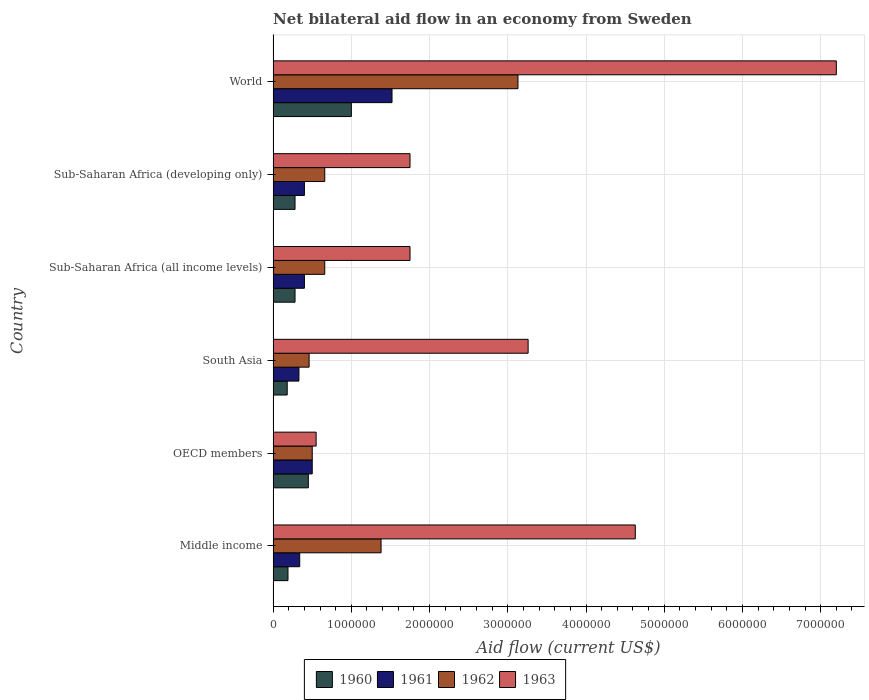How many different coloured bars are there?
Give a very brief answer. 4. How many groups of bars are there?
Give a very brief answer. 6. What is the net bilateral aid flow in 1960 in OECD members?
Make the answer very short. 4.50e+05. Across all countries, what is the maximum net bilateral aid flow in 1963?
Ensure brevity in your answer.  7.20e+06. Across all countries, what is the minimum net bilateral aid flow in 1961?
Provide a succinct answer. 3.30e+05. What is the total net bilateral aid flow in 1960 in the graph?
Provide a succinct answer. 2.38e+06. What is the difference between the net bilateral aid flow in 1960 in Middle income and the net bilateral aid flow in 1963 in World?
Your response must be concise. -7.01e+06. What is the average net bilateral aid flow in 1960 per country?
Provide a short and direct response. 3.97e+05. What is the difference between the net bilateral aid flow in 1962 and net bilateral aid flow in 1960 in Middle income?
Your answer should be very brief. 1.19e+06. In how many countries, is the net bilateral aid flow in 1961 greater than 1600000 US$?
Make the answer very short. 0. What is the ratio of the net bilateral aid flow in 1961 in Sub-Saharan Africa (all income levels) to that in World?
Keep it short and to the point. 0.26. What is the difference between the highest and the second highest net bilateral aid flow in 1963?
Give a very brief answer. 2.57e+06. What is the difference between the highest and the lowest net bilateral aid flow in 1963?
Make the answer very short. 6.65e+06. What does the 1st bar from the top in South Asia represents?
Offer a terse response. 1963. What does the 3rd bar from the bottom in OECD members represents?
Provide a succinct answer. 1962. Is it the case that in every country, the sum of the net bilateral aid flow in 1963 and net bilateral aid flow in 1960 is greater than the net bilateral aid flow in 1962?
Give a very brief answer. Yes. Are all the bars in the graph horizontal?
Provide a short and direct response. Yes. How many countries are there in the graph?
Provide a short and direct response. 6. Are the values on the major ticks of X-axis written in scientific E-notation?
Offer a terse response. No. Does the graph contain any zero values?
Give a very brief answer. No. How are the legend labels stacked?
Your answer should be compact. Horizontal. What is the title of the graph?
Your answer should be compact. Net bilateral aid flow in an economy from Sweden. What is the Aid flow (current US$) in 1962 in Middle income?
Your response must be concise. 1.38e+06. What is the Aid flow (current US$) in 1963 in Middle income?
Your response must be concise. 4.63e+06. What is the Aid flow (current US$) in 1961 in OECD members?
Give a very brief answer. 5.00e+05. What is the Aid flow (current US$) in 1962 in OECD members?
Make the answer very short. 5.00e+05. What is the Aid flow (current US$) in 1963 in OECD members?
Keep it short and to the point. 5.50e+05. What is the Aid flow (current US$) in 1962 in South Asia?
Provide a short and direct response. 4.60e+05. What is the Aid flow (current US$) of 1963 in South Asia?
Your answer should be compact. 3.26e+06. What is the Aid flow (current US$) in 1961 in Sub-Saharan Africa (all income levels)?
Your response must be concise. 4.00e+05. What is the Aid flow (current US$) in 1962 in Sub-Saharan Africa (all income levels)?
Provide a succinct answer. 6.60e+05. What is the Aid flow (current US$) of 1963 in Sub-Saharan Africa (all income levels)?
Your response must be concise. 1.75e+06. What is the Aid flow (current US$) of 1960 in Sub-Saharan Africa (developing only)?
Make the answer very short. 2.80e+05. What is the Aid flow (current US$) in 1961 in Sub-Saharan Africa (developing only)?
Your answer should be compact. 4.00e+05. What is the Aid flow (current US$) in 1962 in Sub-Saharan Africa (developing only)?
Make the answer very short. 6.60e+05. What is the Aid flow (current US$) of 1963 in Sub-Saharan Africa (developing only)?
Ensure brevity in your answer.  1.75e+06. What is the Aid flow (current US$) of 1960 in World?
Offer a terse response. 1.00e+06. What is the Aid flow (current US$) in 1961 in World?
Offer a very short reply. 1.52e+06. What is the Aid flow (current US$) of 1962 in World?
Your answer should be compact. 3.13e+06. What is the Aid flow (current US$) of 1963 in World?
Ensure brevity in your answer.  7.20e+06. Across all countries, what is the maximum Aid flow (current US$) of 1961?
Offer a terse response. 1.52e+06. Across all countries, what is the maximum Aid flow (current US$) of 1962?
Keep it short and to the point. 3.13e+06. Across all countries, what is the maximum Aid flow (current US$) in 1963?
Your response must be concise. 7.20e+06. Across all countries, what is the minimum Aid flow (current US$) of 1960?
Offer a terse response. 1.80e+05. Across all countries, what is the minimum Aid flow (current US$) in 1961?
Offer a terse response. 3.30e+05. Across all countries, what is the minimum Aid flow (current US$) in 1962?
Your answer should be very brief. 4.60e+05. Across all countries, what is the minimum Aid flow (current US$) of 1963?
Provide a succinct answer. 5.50e+05. What is the total Aid flow (current US$) in 1960 in the graph?
Your response must be concise. 2.38e+06. What is the total Aid flow (current US$) in 1961 in the graph?
Make the answer very short. 3.49e+06. What is the total Aid flow (current US$) in 1962 in the graph?
Offer a terse response. 6.79e+06. What is the total Aid flow (current US$) of 1963 in the graph?
Offer a terse response. 1.91e+07. What is the difference between the Aid flow (current US$) in 1960 in Middle income and that in OECD members?
Provide a short and direct response. -2.60e+05. What is the difference between the Aid flow (current US$) of 1962 in Middle income and that in OECD members?
Your answer should be compact. 8.80e+05. What is the difference between the Aid flow (current US$) in 1963 in Middle income and that in OECD members?
Ensure brevity in your answer.  4.08e+06. What is the difference between the Aid flow (current US$) of 1960 in Middle income and that in South Asia?
Keep it short and to the point. 10000. What is the difference between the Aid flow (current US$) in 1961 in Middle income and that in South Asia?
Keep it short and to the point. 10000. What is the difference between the Aid flow (current US$) in 1962 in Middle income and that in South Asia?
Offer a terse response. 9.20e+05. What is the difference between the Aid flow (current US$) in 1963 in Middle income and that in South Asia?
Provide a succinct answer. 1.37e+06. What is the difference between the Aid flow (current US$) of 1962 in Middle income and that in Sub-Saharan Africa (all income levels)?
Your answer should be compact. 7.20e+05. What is the difference between the Aid flow (current US$) in 1963 in Middle income and that in Sub-Saharan Africa (all income levels)?
Give a very brief answer. 2.88e+06. What is the difference between the Aid flow (current US$) of 1962 in Middle income and that in Sub-Saharan Africa (developing only)?
Offer a terse response. 7.20e+05. What is the difference between the Aid flow (current US$) in 1963 in Middle income and that in Sub-Saharan Africa (developing only)?
Your answer should be very brief. 2.88e+06. What is the difference between the Aid flow (current US$) of 1960 in Middle income and that in World?
Provide a short and direct response. -8.10e+05. What is the difference between the Aid flow (current US$) in 1961 in Middle income and that in World?
Ensure brevity in your answer.  -1.18e+06. What is the difference between the Aid flow (current US$) of 1962 in Middle income and that in World?
Ensure brevity in your answer.  -1.75e+06. What is the difference between the Aid flow (current US$) of 1963 in Middle income and that in World?
Give a very brief answer. -2.57e+06. What is the difference between the Aid flow (current US$) in 1960 in OECD members and that in South Asia?
Provide a succinct answer. 2.70e+05. What is the difference between the Aid flow (current US$) of 1963 in OECD members and that in South Asia?
Provide a succinct answer. -2.71e+06. What is the difference between the Aid flow (current US$) of 1960 in OECD members and that in Sub-Saharan Africa (all income levels)?
Offer a very short reply. 1.70e+05. What is the difference between the Aid flow (current US$) of 1961 in OECD members and that in Sub-Saharan Africa (all income levels)?
Your answer should be compact. 1.00e+05. What is the difference between the Aid flow (current US$) of 1963 in OECD members and that in Sub-Saharan Africa (all income levels)?
Offer a very short reply. -1.20e+06. What is the difference between the Aid flow (current US$) of 1960 in OECD members and that in Sub-Saharan Africa (developing only)?
Ensure brevity in your answer.  1.70e+05. What is the difference between the Aid flow (current US$) of 1961 in OECD members and that in Sub-Saharan Africa (developing only)?
Give a very brief answer. 1.00e+05. What is the difference between the Aid flow (current US$) in 1962 in OECD members and that in Sub-Saharan Africa (developing only)?
Your response must be concise. -1.60e+05. What is the difference between the Aid flow (current US$) of 1963 in OECD members and that in Sub-Saharan Africa (developing only)?
Offer a very short reply. -1.20e+06. What is the difference between the Aid flow (current US$) in 1960 in OECD members and that in World?
Your answer should be very brief. -5.50e+05. What is the difference between the Aid flow (current US$) in 1961 in OECD members and that in World?
Offer a terse response. -1.02e+06. What is the difference between the Aid flow (current US$) of 1962 in OECD members and that in World?
Keep it short and to the point. -2.63e+06. What is the difference between the Aid flow (current US$) of 1963 in OECD members and that in World?
Your response must be concise. -6.65e+06. What is the difference between the Aid flow (current US$) in 1961 in South Asia and that in Sub-Saharan Africa (all income levels)?
Provide a short and direct response. -7.00e+04. What is the difference between the Aid flow (current US$) in 1963 in South Asia and that in Sub-Saharan Africa (all income levels)?
Your answer should be compact. 1.51e+06. What is the difference between the Aid flow (current US$) in 1962 in South Asia and that in Sub-Saharan Africa (developing only)?
Ensure brevity in your answer.  -2.00e+05. What is the difference between the Aid flow (current US$) in 1963 in South Asia and that in Sub-Saharan Africa (developing only)?
Provide a short and direct response. 1.51e+06. What is the difference between the Aid flow (current US$) of 1960 in South Asia and that in World?
Ensure brevity in your answer.  -8.20e+05. What is the difference between the Aid flow (current US$) in 1961 in South Asia and that in World?
Offer a terse response. -1.19e+06. What is the difference between the Aid flow (current US$) in 1962 in South Asia and that in World?
Your answer should be very brief. -2.67e+06. What is the difference between the Aid flow (current US$) in 1963 in South Asia and that in World?
Offer a very short reply. -3.94e+06. What is the difference between the Aid flow (current US$) in 1960 in Sub-Saharan Africa (all income levels) and that in Sub-Saharan Africa (developing only)?
Your answer should be very brief. 0. What is the difference between the Aid flow (current US$) in 1962 in Sub-Saharan Africa (all income levels) and that in Sub-Saharan Africa (developing only)?
Offer a very short reply. 0. What is the difference between the Aid flow (current US$) of 1963 in Sub-Saharan Africa (all income levels) and that in Sub-Saharan Africa (developing only)?
Ensure brevity in your answer.  0. What is the difference between the Aid flow (current US$) in 1960 in Sub-Saharan Africa (all income levels) and that in World?
Offer a very short reply. -7.20e+05. What is the difference between the Aid flow (current US$) of 1961 in Sub-Saharan Africa (all income levels) and that in World?
Make the answer very short. -1.12e+06. What is the difference between the Aid flow (current US$) of 1962 in Sub-Saharan Africa (all income levels) and that in World?
Your answer should be compact. -2.47e+06. What is the difference between the Aid flow (current US$) in 1963 in Sub-Saharan Africa (all income levels) and that in World?
Offer a very short reply. -5.45e+06. What is the difference between the Aid flow (current US$) in 1960 in Sub-Saharan Africa (developing only) and that in World?
Make the answer very short. -7.20e+05. What is the difference between the Aid flow (current US$) in 1961 in Sub-Saharan Africa (developing only) and that in World?
Ensure brevity in your answer.  -1.12e+06. What is the difference between the Aid flow (current US$) in 1962 in Sub-Saharan Africa (developing only) and that in World?
Keep it short and to the point. -2.47e+06. What is the difference between the Aid flow (current US$) of 1963 in Sub-Saharan Africa (developing only) and that in World?
Provide a short and direct response. -5.45e+06. What is the difference between the Aid flow (current US$) in 1960 in Middle income and the Aid flow (current US$) in 1961 in OECD members?
Keep it short and to the point. -3.10e+05. What is the difference between the Aid flow (current US$) of 1960 in Middle income and the Aid flow (current US$) of 1962 in OECD members?
Your answer should be very brief. -3.10e+05. What is the difference between the Aid flow (current US$) of 1960 in Middle income and the Aid flow (current US$) of 1963 in OECD members?
Provide a short and direct response. -3.60e+05. What is the difference between the Aid flow (current US$) in 1961 in Middle income and the Aid flow (current US$) in 1963 in OECD members?
Keep it short and to the point. -2.10e+05. What is the difference between the Aid flow (current US$) in 1962 in Middle income and the Aid flow (current US$) in 1963 in OECD members?
Your answer should be very brief. 8.30e+05. What is the difference between the Aid flow (current US$) in 1960 in Middle income and the Aid flow (current US$) in 1963 in South Asia?
Provide a succinct answer. -3.07e+06. What is the difference between the Aid flow (current US$) in 1961 in Middle income and the Aid flow (current US$) in 1962 in South Asia?
Your answer should be compact. -1.20e+05. What is the difference between the Aid flow (current US$) in 1961 in Middle income and the Aid flow (current US$) in 1963 in South Asia?
Keep it short and to the point. -2.92e+06. What is the difference between the Aid flow (current US$) of 1962 in Middle income and the Aid flow (current US$) of 1963 in South Asia?
Your answer should be very brief. -1.88e+06. What is the difference between the Aid flow (current US$) in 1960 in Middle income and the Aid flow (current US$) in 1961 in Sub-Saharan Africa (all income levels)?
Ensure brevity in your answer.  -2.10e+05. What is the difference between the Aid flow (current US$) in 1960 in Middle income and the Aid flow (current US$) in 1962 in Sub-Saharan Africa (all income levels)?
Offer a very short reply. -4.70e+05. What is the difference between the Aid flow (current US$) in 1960 in Middle income and the Aid flow (current US$) in 1963 in Sub-Saharan Africa (all income levels)?
Provide a short and direct response. -1.56e+06. What is the difference between the Aid flow (current US$) in 1961 in Middle income and the Aid flow (current US$) in 1962 in Sub-Saharan Africa (all income levels)?
Keep it short and to the point. -3.20e+05. What is the difference between the Aid flow (current US$) in 1961 in Middle income and the Aid flow (current US$) in 1963 in Sub-Saharan Africa (all income levels)?
Provide a succinct answer. -1.41e+06. What is the difference between the Aid flow (current US$) in 1962 in Middle income and the Aid flow (current US$) in 1963 in Sub-Saharan Africa (all income levels)?
Give a very brief answer. -3.70e+05. What is the difference between the Aid flow (current US$) of 1960 in Middle income and the Aid flow (current US$) of 1962 in Sub-Saharan Africa (developing only)?
Give a very brief answer. -4.70e+05. What is the difference between the Aid flow (current US$) in 1960 in Middle income and the Aid flow (current US$) in 1963 in Sub-Saharan Africa (developing only)?
Provide a short and direct response. -1.56e+06. What is the difference between the Aid flow (current US$) of 1961 in Middle income and the Aid flow (current US$) of 1962 in Sub-Saharan Africa (developing only)?
Make the answer very short. -3.20e+05. What is the difference between the Aid flow (current US$) in 1961 in Middle income and the Aid flow (current US$) in 1963 in Sub-Saharan Africa (developing only)?
Your response must be concise. -1.41e+06. What is the difference between the Aid flow (current US$) in 1962 in Middle income and the Aid flow (current US$) in 1963 in Sub-Saharan Africa (developing only)?
Your response must be concise. -3.70e+05. What is the difference between the Aid flow (current US$) of 1960 in Middle income and the Aid flow (current US$) of 1961 in World?
Make the answer very short. -1.33e+06. What is the difference between the Aid flow (current US$) in 1960 in Middle income and the Aid flow (current US$) in 1962 in World?
Give a very brief answer. -2.94e+06. What is the difference between the Aid flow (current US$) in 1960 in Middle income and the Aid flow (current US$) in 1963 in World?
Your answer should be very brief. -7.01e+06. What is the difference between the Aid flow (current US$) of 1961 in Middle income and the Aid flow (current US$) of 1962 in World?
Your answer should be compact. -2.79e+06. What is the difference between the Aid flow (current US$) in 1961 in Middle income and the Aid flow (current US$) in 1963 in World?
Provide a succinct answer. -6.86e+06. What is the difference between the Aid flow (current US$) of 1962 in Middle income and the Aid flow (current US$) of 1963 in World?
Your response must be concise. -5.82e+06. What is the difference between the Aid flow (current US$) in 1960 in OECD members and the Aid flow (current US$) in 1962 in South Asia?
Your answer should be compact. -10000. What is the difference between the Aid flow (current US$) of 1960 in OECD members and the Aid flow (current US$) of 1963 in South Asia?
Your answer should be compact. -2.81e+06. What is the difference between the Aid flow (current US$) of 1961 in OECD members and the Aid flow (current US$) of 1962 in South Asia?
Your answer should be very brief. 4.00e+04. What is the difference between the Aid flow (current US$) in 1961 in OECD members and the Aid flow (current US$) in 1963 in South Asia?
Keep it short and to the point. -2.76e+06. What is the difference between the Aid flow (current US$) of 1962 in OECD members and the Aid flow (current US$) of 1963 in South Asia?
Make the answer very short. -2.76e+06. What is the difference between the Aid flow (current US$) of 1960 in OECD members and the Aid flow (current US$) of 1963 in Sub-Saharan Africa (all income levels)?
Offer a very short reply. -1.30e+06. What is the difference between the Aid flow (current US$) in 1961 in OECD members and the Aid flow (current US$) in 1962 in Sub-Saharan Africa (all income levels)?
Make the answer very short. -1.60e+05. What is the difference between the Aid flow (current US$) in 1961 in OECD members and the Aid flow (current US$) in 1963 in Sub-Saharan Africa (all income levels)?
Provide a succinct answer. -1.25e+06. What is the difference between the Aid flow (current US$) in 1962 in OECD members and the Aid flow (current US$) in 1963 in Sub-Saharan Africa (all income levels)?
Make the answer very short. -1.25e+06. What is the difference between the Aid flow (current US$) of 1960 in OECD members and the Aid flow (current US$) of 1961 in Sub-Saharan Africa (developing only)?
Your answer should be compact. 5.00e+04. What is the difference between the Aid flow (current US$) in 1960 in OECD members and the Aid flow (current US$) in 1962 in Sub-Saharan Africa (developing only)?
Keep it short and to the point. -2.10e+05. What is the difference between the Aid flow (current US$) in 1960 in OECD members and the Aid flow (current US$) in 1963 in Sub-Saharan Africa (developing only)?
Provide a short and direct response. -1.30e+06. What is the difference between the Aid flow (current US$) in 1961 in OECD members and the Aid flow (current US$) in 1962 in Sub-Saharan Africa (developing only)?
Provide a succinct answer. -1.60e+05. What is the difference between the Aid flow (current US$) of 1961 in OECD members and the Aid flow (current US$) of 1963 in Sub-Saharan Africa (developing only)?
Offer a terse response. -1.25e+06. What is the difference between the Aid flow (current US$) of 1962 in OECD members and the Aid flow (current US$) of 1963 in Sub-Saharan Africa (developing only)?
Make the answer very short. -1.25e+06. What is the difference between the Aid flow (current US$) in 1960 in OECD members and the Aid flow (current US$) in 1961 in World?
Your answer should be very brief. -1.07e+06. What is the difference between the Aid flow (current US$) in 1960 in OECD members and the Aid flow (current US$) in 1962 in World?
Provide a short and direct response. -2.68e+06. What is the difference between the Aid flow (current US$) of 1960 in OECD members and the Aid flow (current US$) of 1963 in World?
Offer a terse response. -6.75e+06. What is the difference between the Aid flow (current US$) in 1961 in OECD members and the Aid flow (current US$) in 1962 in World?
Keep it short and to the point. -2.63e+06. What is the difference between the Aid flow (current US$) in 1961 in OECD members and the Aid flow (current US$) in 1963 in World?
Ensure brevity in your answer.  -6.70e+06. What is the difference between the Aid flow (current US$) of 1962 in OECD members and the Aid flow (current US$) of 1963 in World?
Your answer should be compact. -6.70e+06. What is the difference between the Aid flow (current US$) in 1960 in South Asia and the Aid flow (current US$) in 1961 in Sub-Saharan Africa (all income levels)?
Ensure brevity in your answer.  -2.20e+05. What is the difference between the Aid flow (current US$) of 1960 in South Asia and the Aid flow (current US$) of 1962 in Sub-Saharan Africa (all income levels)?
Give a very brief answer. -4.80e+05. What is the difference between the Aid flow (current US$) of 1960 in South Asia and the Aid flow (current US$) of 1963 in Sub-Saharan Africa (all income levels)?
Your answer should be compact. -1.57e+06. What is the difference between the Aid flow (current US$) of 1961 in South Asia and the Aid flow (current US$) of 1962 in Sub-Saharan Africa (all income levels)?
Your answer should be very brief. -3.30e+05. What is the difference between the Aid flow (current US$) in 1961 in South Asia and the Aid flow (current US$) in 1963 in Sub-Saharan Africa (all income levels)?
Provide a succinct answer. -1.42e+06. What is the difference between the Aid flow (current US$) of 1962 in South Asia and the Aid flow (current US$) of 1963 in Sub-Saharan Africa (all income levels)?
Your answer should be compact. -1.29e+06. What is the difference between the Aid flow (current US$) in 1960 in South Asia and the Aid flow (current US$) in 1962 in Sub-Saharan Africa (developing only)?
Your answer should be compact. -4.80e+05. What is the difference between the Aid flow (current US$) of 1960 in South Asia and the Aid flow (current US$) of 1963 in Sub-Saharan Africa (developing only)?
Make the answer very short. -1.57e+06. What is the difference between the Aid flow (current US$) in 1961 in South Asia and the Aid flow (current US$) in 1962 in Sub-Saharan Africa (developing only)?
Give a very brief answer. -3.30e+05. What is the difference between the Aid flow (current US$) in 1961 in South Asia and the Aid flow (current US$) in 1963 in Sub-Saharan Africa (developing only)?
Your response must be concise. -1.42e+06. What is the difference between the Aid flow (current US$) of 1962 in South Asia and the Aid flow (current US$) of 1963 in Sub-Saharan Africa (developing only)?
Keep it short and to the point. -1.29e+06. What is the difference between the Aid flow (current US$) in 1960 in South Asia and the Aid flow (current US$) in 1961 in World?
Make the answer very short. -1.34e+06. What is the difference between the Aid flow (current US$) of 1960 in South Asia and the Aid flow (current US$) of 1962 in World?
Offer a terse response. -2.95e+06. What is the difference between the Aid flow (current US$) of 1960 in South Asia and the Aid flow (current US$) of 1963 in World?
Offer a terse response. -7.02e+06. What is the difference between the Aid flow (current US$) in 1961 in South Asia and the Aid flow (current US$) in 1962 in World?
Offer a very short reply. -2.80e+06. What is the difference between the Aid flow (current US$) in 1961 in South Asia and the Aid flow (current US$) in 1963 in World?
Provide a succinct answer. -6.87e+06. What is the difference between the Aid flow (current US$) in 1962 in South Asia and the Aid flow (current US$) in 1963 in World?
Offer a terse response. -6.74e+06. What is the difference between the Aid flow (current US$) in 1960 in Sub-Saharan Africa (all income levels) and the Aid flow (current US$) in 1961 in Sub-Saharan Africa (developing only)?
Your answer should be compact. -1.20e+05. What is the difference between the Aid flow (current US$) in 1960 in Sub-Saharan Africa (all income levels) and the Aid flow (current US$) in 1962 in Sub-Saharan Africa (developing only)?
Your answer should be very brief. -3.80e+05. What is the difference between the Aid flow (current US$) in 1960 in Sub-Saharan Africa (all income levels) and the Aid flow (current US$) in 1963 in Sub-Saharan Africa (developing only)?
Keep it short and to the point. -1.47e+06. What is the difference between the Aid flow (current US$) in 1961 in Sub-Saharan Africa (all income levels) and the Aid flow (current US$) in 1962 in Sub-Saharan Africa (developing only)?
Your answer should be compact. -2.60e+05. What is the difference between the Aid flow (current US$) of 1961 in Sub-Saharan Africa (all income levels) and the Aid flow (current US$) of 1963 in Sub-Saharan Africa (developing only)?
Give a very brief answer. -1.35e+06. What is the difference between the Aid flow (current US$) of 1962 in Sub-Saharan Africa (all income levels) and the Aid flow (current US$) of 1963 in Sub-Saharan Africa (developing only)?
Keep it short and to the point. -1.09e+06. What is the difference between the Aid flow (current US$) in 1960 in Sub-Saharan Africa (all income levels) and the Aid flow (current US$) in 1961 in World?
Offer a terse response. -1.24e+06. What is the difference between the Aid flow (current US$) of 1960 in Sub-Saharan Africa (all income levels) and the Aid flow (current US$) of 1962 in World?
Provide a succinct answer. -2.85e+06. What is the difference between the Aid flow (current US$) in 1960 in Sub-Saharan Africa (all income levels) and the Aid flow (current US$) in 1963 in World?
Ensure brevity in your answer.  -6.92e+06. What is the difference between the Aid flow (current US$) of 1961 in Sub-Saharan Africa (all income levels) and the Aid flow (current US$) of 1962 in World?
Provide a succinct answer. -2.73e+06. What is the difference between the Aid flow (current US$) of 1961 in Sub-Saharan Africa (all income levels) and the Aid flow (current US$) of 1963 in World?
Your answer should be compact. -6.80e+06. What is the difference between the Aid flow (current US$) of 1962 in Sub-Saharan Africa (all income levels) and the Aid flow (current US$) of 1963 in World?
Keep it short and to the point. -6.54e+06. What is the difference between the Aid flow (current US$) of 1960 in Sub-Saharan Africa (developing only) and the Aid flow (current US$) of 1961 in World?
Offer a very short reply. -1.24e+06. What is the difference between the Aid flow (current US$) in 1960 in Sub-Saharan Africa (developing only) and the Aid flow (current US$) in 1962 in World?
Your answer should be compact. -2.85e+06. What is the difference between the Aid flow (current US$) of 1960 in Sub-Saharan Africa (developing only) and the Aid flow (current US$) of 1963 in World?
Keep it short and to the point. -6.92e+06. What is the difference between the Aid flow (current US$) in 1961 in Sub-Saharan Africa (developing only) and the Aid flow (current US$) in 1962 in World?
Provide a succinct answer. -2.73e+06. What is the difference between the Aid flow (current US$) of 1961 in Sub-Saharan Africa (developing only) and the Aid flow (current US$) of 1963 in World?
Make the answer very short. -6.80e+06. What is the difference between the Aid flow (current US$) of 1962 in Sub-Saharan Africa (developing only) and the Aid flow (current US$) of 1963 in World?
Your response must be concise. -6.54e+06. What is the average Aid flow (current US$) of 1960 per country?
Keep it short and to the point. 3.97e+05. What is the average Aid flow (current US$) in 1961 per country?
Provide a short and direct response. 5.82e+05. What is the average Aid flow (current US$) of 1962 per country?
Provide a short and direct response. 1.13e+06. What is the average Aid flow (current US$) of 1963 per country?
Provide a succinct answer. 3.19e+06. What is the difference between the Aid flow (current US$) of 1960 and Aid flow (current US$) of 1962 in Middle income?
Offer a very short reply. -1.19e+06. What is the difference between the Aid flow (current US$) in 1960 and Aid flow (current US$) in 1963 in Middle income?
Provide a succinct answer. -4.44e+06. What is the difference between the Aid flow (current US$) in 1961 and Aid flow (current US$) in 1962 in Middle income?
Your answer should be very brief. -1.04e+06. What is the difference between the Aid flow (current US$) of 1961 and Aid flow (current US$) of 1963 in Middle income?
Your answer should be compact. -4.29e+06. What is the difference between the Aid flow (current US$) of 1962 and Aid flow (current US$) of 1963 in Middle income?
Your answer should be very brief. -3.25e+06. What is the difference between the Aid flow (current US$) of 1960 and Aid flow (current US$) of 1962 in OECD members?
Offer a very short reply. -5.00e+04. What is the difference between the Aid flow (current US$) in 1960 and Aid flow (current US$) in 1963 in OECD members?
Keep it short and to the point. -1.00e+05. What is the difference between the Aid flow (current US$) of 1961 and Aid flow (current US$) of 1962 in OECD members?
Provide a short and direct response. 0. What is the difference between the Aid flow (current US$) of 1960 and Aid flow (current US$) of 1962 in South Asia?
Give a very brief answer. -2.80e+05. What is the difference between the Aid flow (current US$) in 1960 and Aid flow (current US$) in 1963 in South Asia?
Your answer should be very brief. -3.08e+06. What is the difference between the Aid flow (current US$) in 1961 and Aid flow (current US$) in 1962 in South Asia?
Your response must be concise. -1.30e+05. What is the difference between the Aid flow (current US$) of 1961 and Aid flow (current US$) of 1963 in South Asia?
Offer a terse response. -2.93e+06. What is the difference between the Aid flow (current US$) in 1962 and Aid flow (current US$) in 1963 in South Asia?
Give a very brief answer. -2.80e+06. What is the difference between the Aid flow (current US$) in 1960 and Aid flow (current US$) in 1961 in Sub-Saharan Africa (all income levels)?
Ensure brevity in your answer.  -1.20e+05. What is the difference between the Aid flow (current US$) of 1960 and Aid flow (current US$) of 1962 in Sub-Saharan Africa (all income levels)?
Make the answer very short. -3.80e+05. What is the difference between the Aid flow (current US$) in 1960 and Aid flow (current US$) in 1963 in Sub-Saharan Africa (all income levels)?
Offer a very short reply. -1.47e+06. What is the difference between the Aid flow (current US$) in 1961 and Aid flow (current US$) in 1962 in Sub-Saharan Africa (all income levels)?
Offer a very short reply. -2.60e+05. What is the difference between the Aid flow (current US$) in 1961 and Aid flow (current US$) in 1963 in Sub-Saharan Africa (all income levels)?
Keep it short and to the point. -1.35e+06. What is the difference between the Aid flow (current US$) of 1962 and Aid flow (current US$) of 1963 in Sub-Saharan Africa (all income levels)?
Offer a very short reply. -1.09e+06. What is the difference between the Aid flow (current US$) of 1960 and Aid flow (current US$) of 1961 in Sub-Saharan Africa (developing only)?
Offer a terse response. -1.20e+05. What is the difference between the Aid flow (current US$) of 1960 and Aid flow (current US$) of 1962 in Sub-Saharan Africa (developing only)?
Make the answer very short. -3.80e+05. What is the difference between the Aid flow (current US$) of 1960 and Aid flow (current US$) of 1963 in Sub-Saharan Africa (developing only)?
Your answer should be very brief. -1.47e+06. What is the difference between the Aid flow (current US$) of 1961 and Aid flow (current US$) of 1963 in Sub-Saharan Africa (developing only)?
Your response must be concise. -1.35e+06. What is the difference between the Aid flow (current US$) of 1962 and Aid flow (current US$) of 1963 in Sub-Saharan Africa (developing only)?
Give a very brief answer. -1.09e+06. What is the difference between the Aid flow (current US$) in 1960 and Aid flow (current US$) in 1961 in World?
Provide a short and direct response. -5.20e+05. What is the difference between the Aid flow (current US$) of 1960 and Aid flow (current US$) of 1962 in World?
Provide a short and direct response. -2.13e+06. What is the difference between the Aid flow (current US$) in 1960 and Aid flow (current US$) in 1963 in World?
Provide a short and direct response. -6.20e+06. What is the difference between the Aid flow (current US$) of 1961 and Aid flow (current US$) of 1962 in World?
Provide a short and direct response. -1.61e+06. What is the difference between the Aid flow (current US$) of 1961 and Aid flow (current US$) of 1963 in World?
Make the answer very short. -5.68e+06. What is the difference between the Aid flow (current US$) in 1962 and Aid flow (current US$) in 1963 in World?
Your answer should be compact. -4.07e+06. What is the ratio of the Aid flow (current US$) in 1960 in Middle income to that in OECD members?
Offer a very short reply. 0.42. What is the ratio of the Aid flow (current US$) of 1961 in Middle income to that in OECD members?
Ensure brevity in your answer.  0.68. What is the ratio of the Aid flow (current US$) of 1962 in Middle income to that in OECD members?
Your answer should be compact. 2.76. What is the ratio of the Aid flow (current US$) of 1963 in Middle income to that in OECD members?
Your response must be concise. 8.42. What is the ratio of the Aid flow (current US$) in 1960 in Middle income to that in South Asia?
Keep it short and to the point. 1.06. What is the ratio of the Aid flow (current US$) of 1961 in Middle income to that in South Asia?
Give a very brief answer. 1.03. What is the ratio of the Aid flow (current US$) in 1963 in Middle income to that in South Asia?
Provide a short and direct response. 1.42. What is the ratio of the Aid flow (current US$) in 1960 in Middle income to that in Sub-Saharan Africa (all income levels)?
Offer a terse response. 0.68. What is the ratio of the Aid flow (current US$) in 1961 in Middle income to that in Sub-Saharan Africa (all income levels)?
Offer a very short reply. 0.85. What is the ratio of the Aid flow (current US$) in 1962 in Middle income to that in Sub-Saharan Africa (all income levels)?
Ensure brevity in your answer.  2.09. What is the ratio of the Aid flow (current US$) in 1963 in Middle income to that in Sub-Saharan Africa (all income levels)?
Offer a terse response. 2.65. What is the ratio of the Aid flow (current US$) of 1960 in Middle income to that in Sub-Saharan Africa (developing only)?
Your response must be concise. 0.68. What is the ratio of the Aid flow (current US$) in 1961 in Middle income to that in Sub-Saharan Africa (developing only)?
Provide a succinct answer. 0.85. What is the ratio of the Aid flow (current US$) of 1962 in Middle income to that in Sub-Saharan Africa (developing only)?
Offer a terse response. 2.09. What is the ratio of the Aid flow (current US$) in 1963 in Middle income to that in Sub-Saharan Africa (developing only)?
Your answer should be very brief. 2.65. What is the ratio of the Aid flow (current US$) in 1960 in Middle income to that in World?
Offer a terse response. 0.19. What is the ratio of the Aid flow (current US$) of 1961 in Middle income to that in World?
Provide a short and direct response. 0.22. What is the ratio of the Aid flow (current US$) in 1962 in Middle income to that in World?
Your response must be concise. 0.44. What is the ratio of the Aid flow (current US$) in 1963 in Middle income to that in World?
Keep it short and to the point. 0.64. What is the ratio of the Aid flow (current US$) in 1960 in OECD members to that in South Asia?
Offer a terse response. 2.5. What is the ratio of the Aid flow (current US$) in 1961 in OECD members to that in South Asia?
Your answer should be compact. 1.52. What is the ratio of the Aid flow (current US$) in 1962 in OECD members to that in South Asia?
Your response must be concise. 1.09. What is the ratio of the Aid flow (current US$) of 1963 in OECD members to that in South Asia?
Provide a succinct answer. 0.17. What is the ratio of the Aid flow (current US$) in 1960 in OECD members to that in Sub-Saharan Africa (all income levels)?
Keep it short and to the point. 1.61. What is the ratio of the Aid flow (current US$) of 1962 in OECD members to that in Sub-Saharan Africa (all income levels)?
Your answer should be compact. 0.76. What is the ratio of the Aid flow (current US$) in 1963 in OECD members to that in Sub-Saharan Africa (all income levels)?
Your response must be concise. 0.31. What is the ratio of the Aid flow (current US$) in 1960 in OECD members to that in Sub-Saharan Africa (developing only)?
Offer a terse response. 1.61. What is the ratio of the Aid flow (current US$) of 1961 in OECD members to that in Sub-Saharan Africa (developing only)?
Your answer should be very brief. 1.25. What is the ratio of the Aid flow (current US$) in 1962 in OECD members to that in Sub-Saharan Africa (developing only)?
Provide a short and direct response. 0.76. What is the ratio of the Aid flow (current US$) of 1963 in OECD members to that in Sub-Saharan Africa (developing only)?
Keep it short and to the point. 0.31. What is the ratio of the Aid flow (current US$) of 1960 in OECD members to that in World?
Your answer should be compact. 0.45. What is the ratio of the Aid flow (current US$) in 1961 in OECD members to that in World?
Your response must be concise. 0.33. What is the ratio of the Aid flow (current US$) of 1962 in OECD members to that in World?
Ensure brevity in your answer.  0.16. What is the ratio of the Aid flow (current US$) in 1963 in OECD members to that in World?
Your answer should be compact. 0.08. What is the ratio of the Aid flow (current US$) in 1960 in South Asia to that in Sub-Saharan Africa (all income levels)?
Make the answer very short. 0.64. What is the ratio of the Aid flow (current US$) in 1961 in South Asia to that in Sub-Saharan Africa (all income levels)?
Ensure brevity in your answer.  0.82. What is the ratio of the Aid flow (current US$) in 1962 in South Asia to that in Sub-Saharan Africa (all income levels)?
Offer a terse response. 0.7. What is the ratio of the Aid flow (current US$) of 1963 in South Asia to that in Sub-Saharan Africa (all income levels)?
Provide a short and direct response. 1.86. What is the ratio of the Aid flow (current US$) in 1960 in South Asia to that in Sub-Saharan Africa (developing only)?
Give a very brief answer. 0.64. What is the ratio of the Aid flow (current US$) of 1961 in South Asia to that in Sub-Saharan Africa (developing only)?
Ensure brevity in your answer.  0.82. What is the ratio of the Aid flow (current US$) of 1962 in South Asia to that in Sub-Saharan Africa (developing only)?
Offer a terse response. 0.7. What is the ratio of the Aid flow (current US$) of 1963 in South Asia to that in Sub-Saharan Africa (developing only)?
Your answer should be very brief. 1.86. What is the ratio of the Aid flow (current US$) of 1960 in South Asia to that in World?
Your answer should be compact. 0.18. What is the ratio of the Aid flow (current US$) of 1961 in South Asia to that in World?
Give a very brief answer. 0.22. What is the ratio of the Aid flow (current US$) in 1962 in South Asia to that in World?
Your answer should be compact. 0.15. What is the ratio of the Aid flow (current US$) of 1963 in South Asia to that in World?
Offer a terse response. 0.45. What is the ratio of the Aid flow (current US$) in 1960 in Sub-Saharan Africa (all income levels) to that in Sub-Saharan Africa (developing only)?
Your response must be concise. 1. What is the ratio of the Aid flow (current US$) of 1961 in Sub-Saharan Africa (all income levels) to that in Sub-Saharan Africa (developing only)?
Give a very brief answer. 1. What is the ratio of the Aid flow (current US$) of 1960 in Sub-Saharan Africa (all income levels) to that in World?
Provide a succinct answer. 0.28. What is the ratio of the Aid flow (current US$) in 1961 in Sub-Saharan Africa (all income levels) to that in World?
Give a very brief answer. 0.26. What is the ratio of the Aid flow (current US$) in 1962 in Sub-Saharan Africa (all income levels) to that in World?
Offer a terse response. 0.21. What is the ratio of the Aid flow (current US$) of 1963 in Sub-Saharan Africa (all income levels) to that in World?
Offer a very short reply. 0.24. What is the ratio of the Aid flow (current US$) of 1960 in Sub-Saharan Africa (developing only) to that in World?
Make the answer very short. 0.28. What is the ratio of the Aid flow (current US$) in 1961 in Sub-Saharan Africa (developing only) to that in World?
Your response must be concise. 0.26. What is the ratio of the Aid flow (current US$) of 1962 in Sub-Saharan Africa (developing only) to that in World?
Give a very brief answer. 0.21. What is the ratio of the Aid flow (current US$) in 1963 in Sub-Saharan Africa (developing only) to that in World?
Offer a very short reply. 0.24. What is the difference between the highest and the second highest Aid flow (current US$) in 1961?
Provide a succinct answer. 1.02e+06. What is the difference between the highest and the second highest Aid flow (current US$) of 1962?
Offer a very short reply. 1.75e+06. What is the difference between the highest and the second highest Aid flow (current US$) in 1963?
Provide a succinct answer. 2.57e+06. What is the difference between the highest and the lowest Aid flow (current US$) of 1960?
Offer a very short reply. 8.20e+05. What is the difference between the highest and the lowest Aid flow (current US$) of 1961?
Your answer should be very brief. 1.19e+06. What is the difference between the highest and the lowest Aid flow (current US$) in 1962?
Provide a succinct answer. 2.67e+06. What is the difference between the highest and the lowest Aid flow (current US$) of 1963?
Your response must be concise. 6.65e+06. 